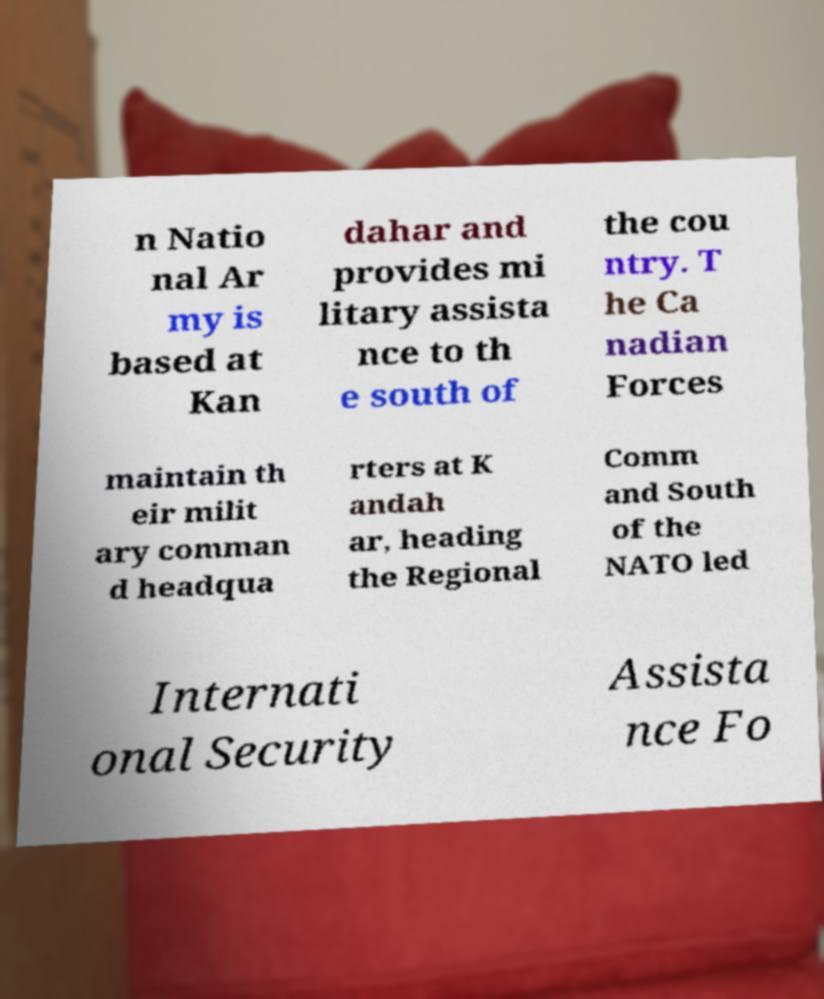Could you assist in decoding the text presented in this image and type it out clearly? n Natio nal Ar my is based at Kan dahar and provides mi litary assista nce to th e south of the cou ntry. T he Ca nadian Forces maintain th eir milit ary comman d headqua rters at K andah ar, heading the Regional Comm and South of the NATO led Internati onal Security Assista nce Fo 